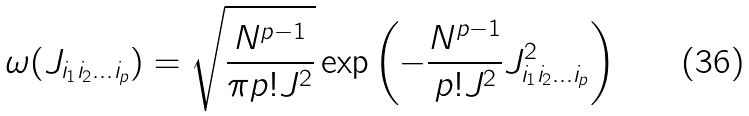<formula> <loc_0><loc_0><loc_500><loc_500>\omega ( J _ { i _ { 1 } i _ { 2 } \dots i _ { p } } ) = \sqrt { \frac { N ^ { p - 1 } } { \pi p ! J ^ { 2 } } } \exp \left ( - \frac { N ^ { p - 1 } } { p ! J ^ { 2 } } J _ { i _ { 1 } i _ { 2 } \dots i _ { p } } ^ { 2 } \right )</formula> 